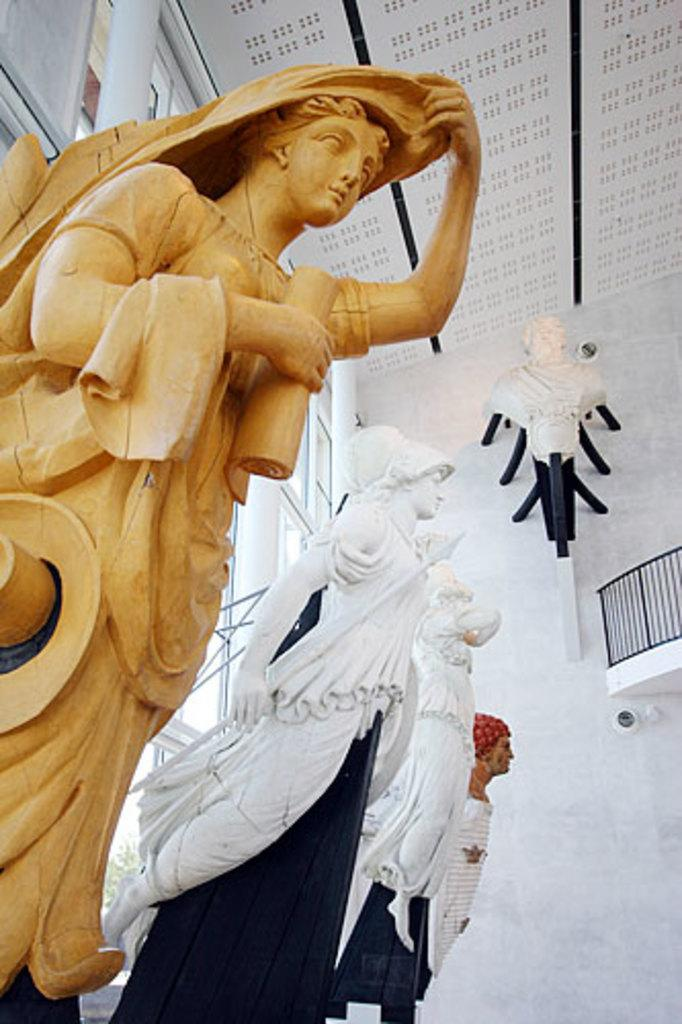What type of objects can be seen in the image? There are statues in the image. What architectural feature is present in the image? There is a wall in the image. What type of barrier is visible in the image? There is railing in the image. What type of structural elements can be seen in the image? There are rods and poles in the image. What type of object made of glass is present in the image? There is a glass object in the image. What part of the building is visible at the top of the image? The ceiling is visible at the top of the image. How does the coach increase the temperature in the image? There is no coach present in the image, so it is not possible to determine how it might increase the temperature. 